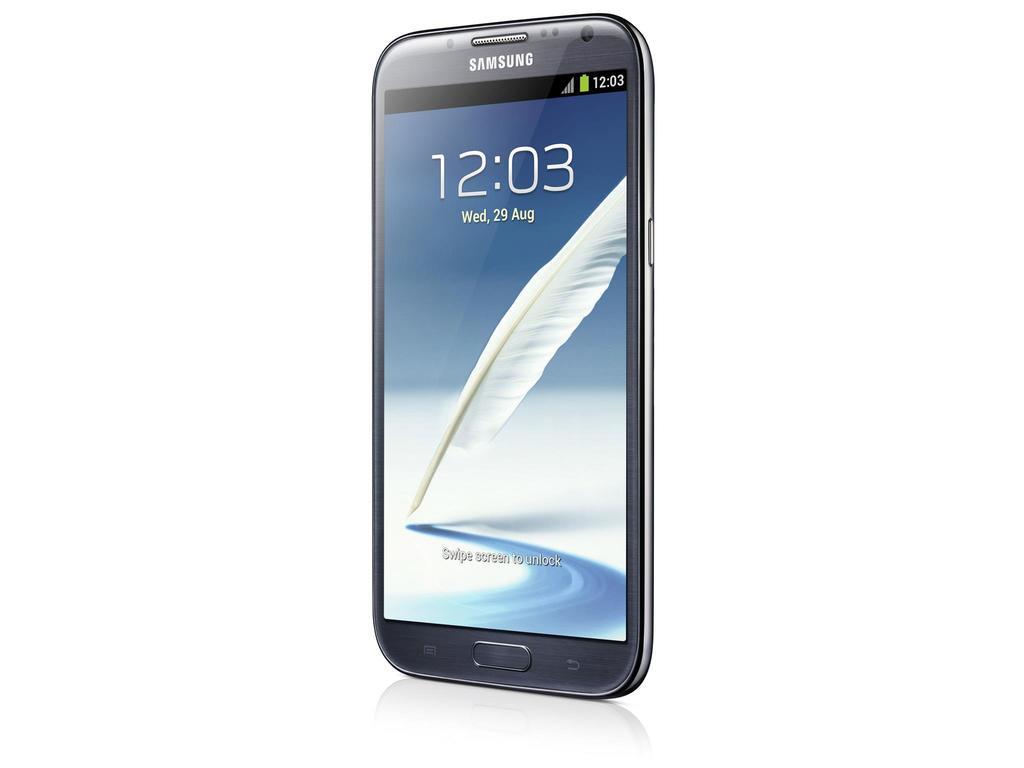What time is it on the phone?
Make the answer very short. 12:03. What brand of phone is shown?
Your answer should be compact. Samsung. 